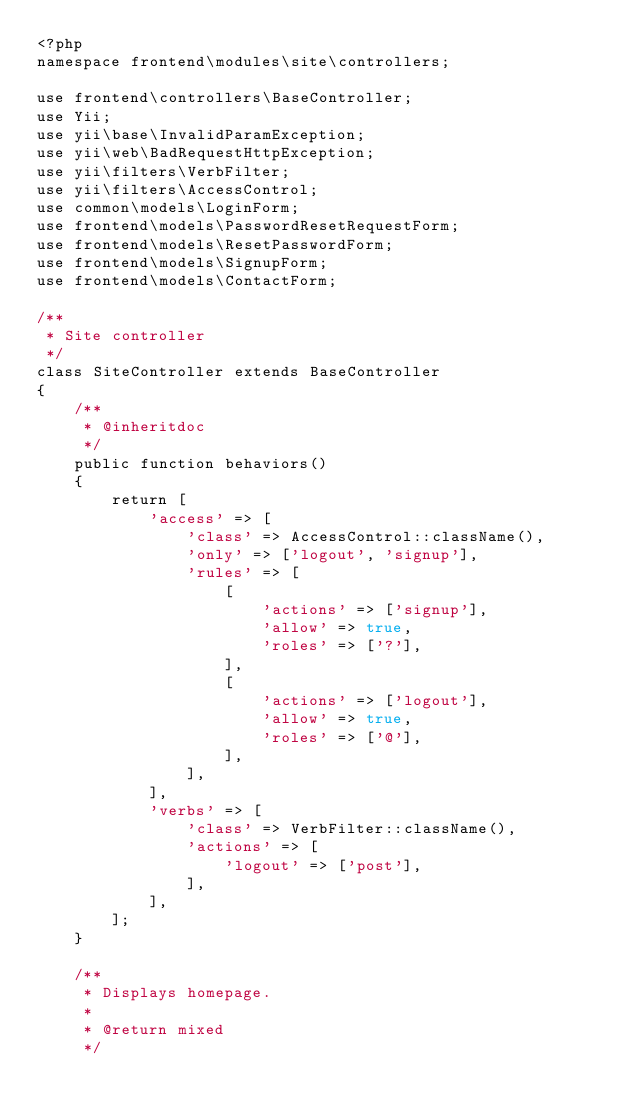<code> <loc_0><loc_0><loc_500><loc_500><_PHP_><?php
namespace frontend\modules\site\controllers;

use frontend\controllers\BaseController;
use Yii;
use yii\base\InvalidParamException;
use yii\web\BadRequestHttpException;
use yii\filters\VerbFilter;
use yii\filters\AccessControl;
use common\models\LoginForm;
use frontend\models\PasswordResetRequestForm;
use frontend\models\ResetPasswordForm;
use frontend\models\SignupForm;
use frontend\models\ContactForm;

/**
 * Site controller
 */
class SiteController extends BaseController
{
    /**
     * @inheritdoc
     */
    public function behaviors()
    {
        return [
            'access' => [
                'class' => AccessControl::className(),
                'only' => ['logout', 'signup'],
                'rules' => [
                    [
                        'actions' => ['signup'],
                        'allow' => true,
                        'roles' => ['?'],
                    ],
                    [
                        'actions' => ['logout'],
                        'allow' => true,
                        'roles' => ['@'],
                    ],
                ],
            ],
            'verbs' => [
                'class' => VerbFilter::className(),
                'actions' => [
                    'logout' => ['post'],
                ],
            ],
        ];
    }

    /**
     * Displays homepage.
     *
     * @return mixed
     */</code> 